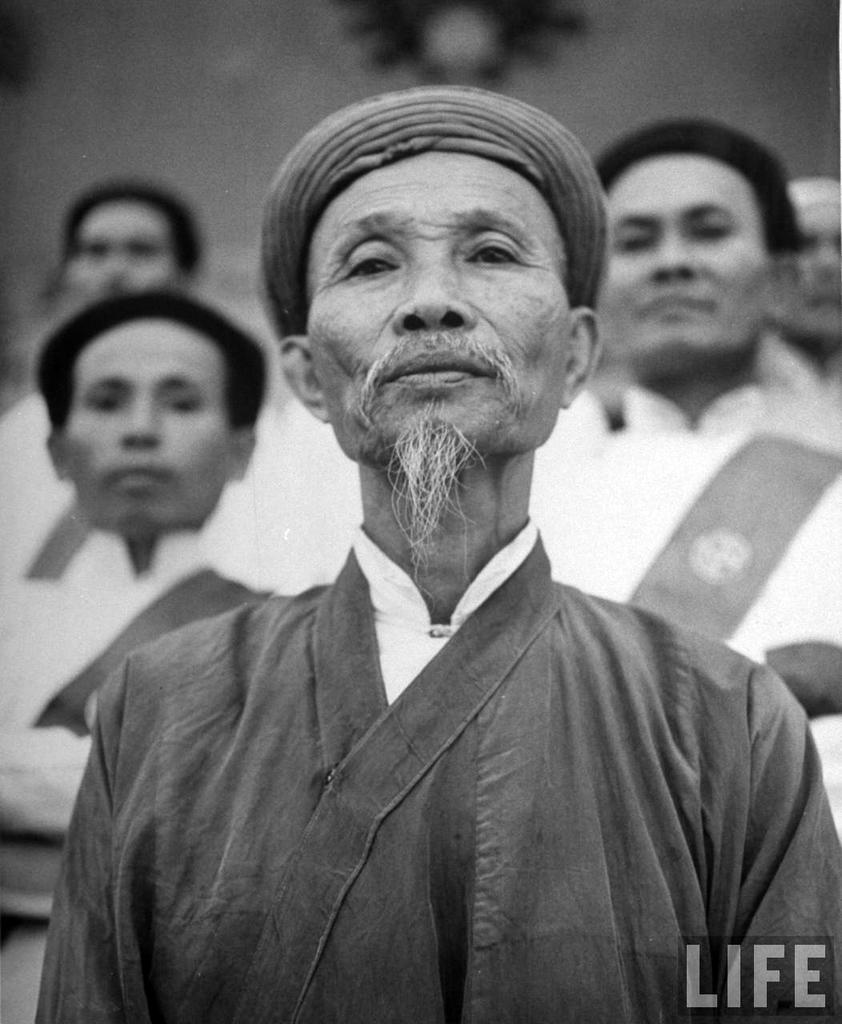What is the color scheme of the image? The image is black and white. Who is present in the image? There are men in the image. What are the men doing in the image? The men are looking at a picture. Can you describe the background of the image? The background of the image is blurred. Where is the text located in the image? The text is in the bottom right corner of the image. What is the reason for the quicksand in the image? There is no quicksand present in the image. How does the power affect the men in the image? There is no mention of power or its effects on the men in the image. 